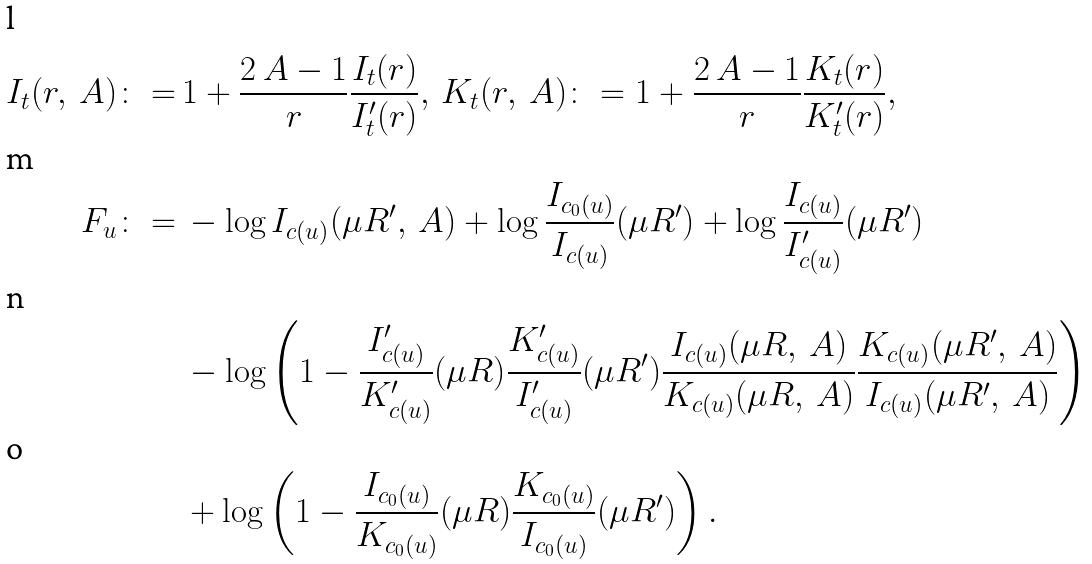<formula> <loc_0><loc_0><loc_500><loc_500>I _ { t } ( r , \ A ) \colon = \, & 1 + \frac { 2 \ A - 1 } { r } \frac { I _ { t } ( r ) } { I ^ { \prime } _ { t } ( r ) } , \ K _ { t } ( r , \ A ) \colon = 1 + \frac { 2 \ A - 1 } { r } \frac { K _ { t } ( r ) } { K ^ { \prime } _ { t } ( r ) } , \\ F _ { u } \colon = \, & - \log I _ { c ( u ) } ( \mu R ^ { \prime } , \ A ) + \log \frac { I _ { c _ { 0 } ( u ) } } { I _ { c ( u ) } } ( \mu R ^ { \prime } ) + \log \frac { I _ { c ( u ) } } { I ^ { \prime } _ { c ( u ) } } ( \mu R ^ { \prime } ) \\ & - \log \left ( 1 - \frac { I ^ { \prime } _ { c ( u ) } } { K ^ { \prime } _ { c ( u ) } } ( \mu R ) \frac { K ^ { \prime } _ { c ( u ) } } { I ^ { \prime } _ { c ( u ) } } ( \mu R ^ { \prime } ) \frac { I _ { c ( u ) } ( \mu R , \ A ) } { K _ { c ( u ) } ( \mu R , \ A ) } \frac { K _ { c ( u ) } ( \mu R ^ { \prime } , \ A ) } { I _ { c ( u ) } ( \mu R ^ { \prime } , \ A ) } \right ) \\ & + \log \left ( 1 - \frac { I _ { c _ { 0 } ( u ) } } { K _ { c _ { 0 } ( u ) } } ( \mu R ) \frac { K _ { c _ { 0 } ( u ) } } { I _ { c _ { 0 } ( u ) } } ( \mu R ^ { \prime } ) \right ) .</formula> 